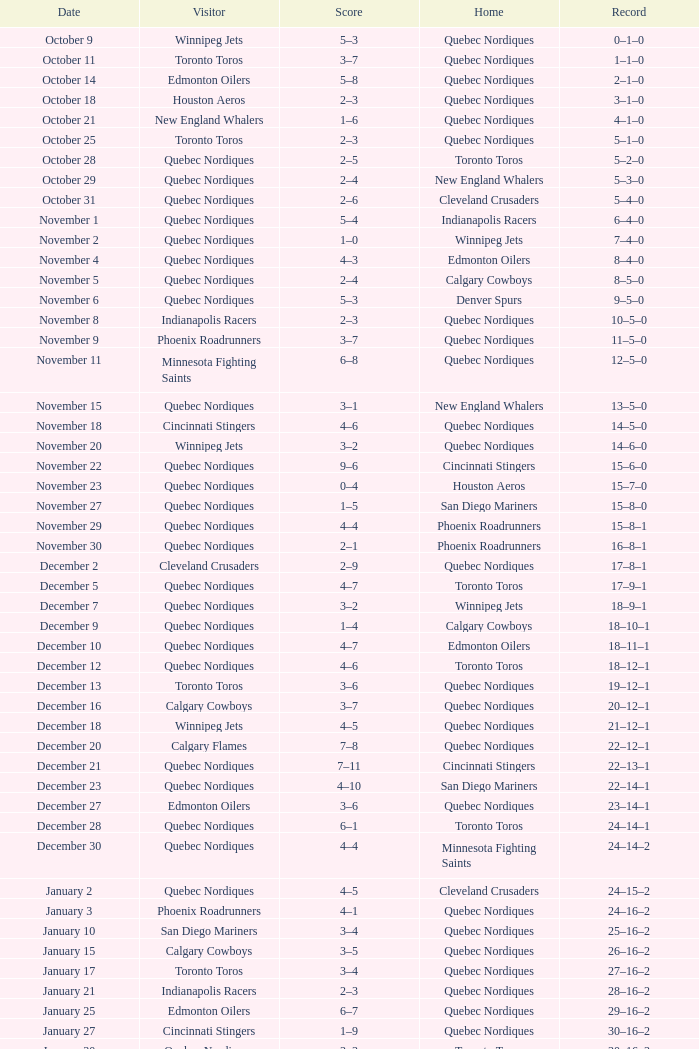What was the tally of the game when the record was 39-21-4? 5–4. 